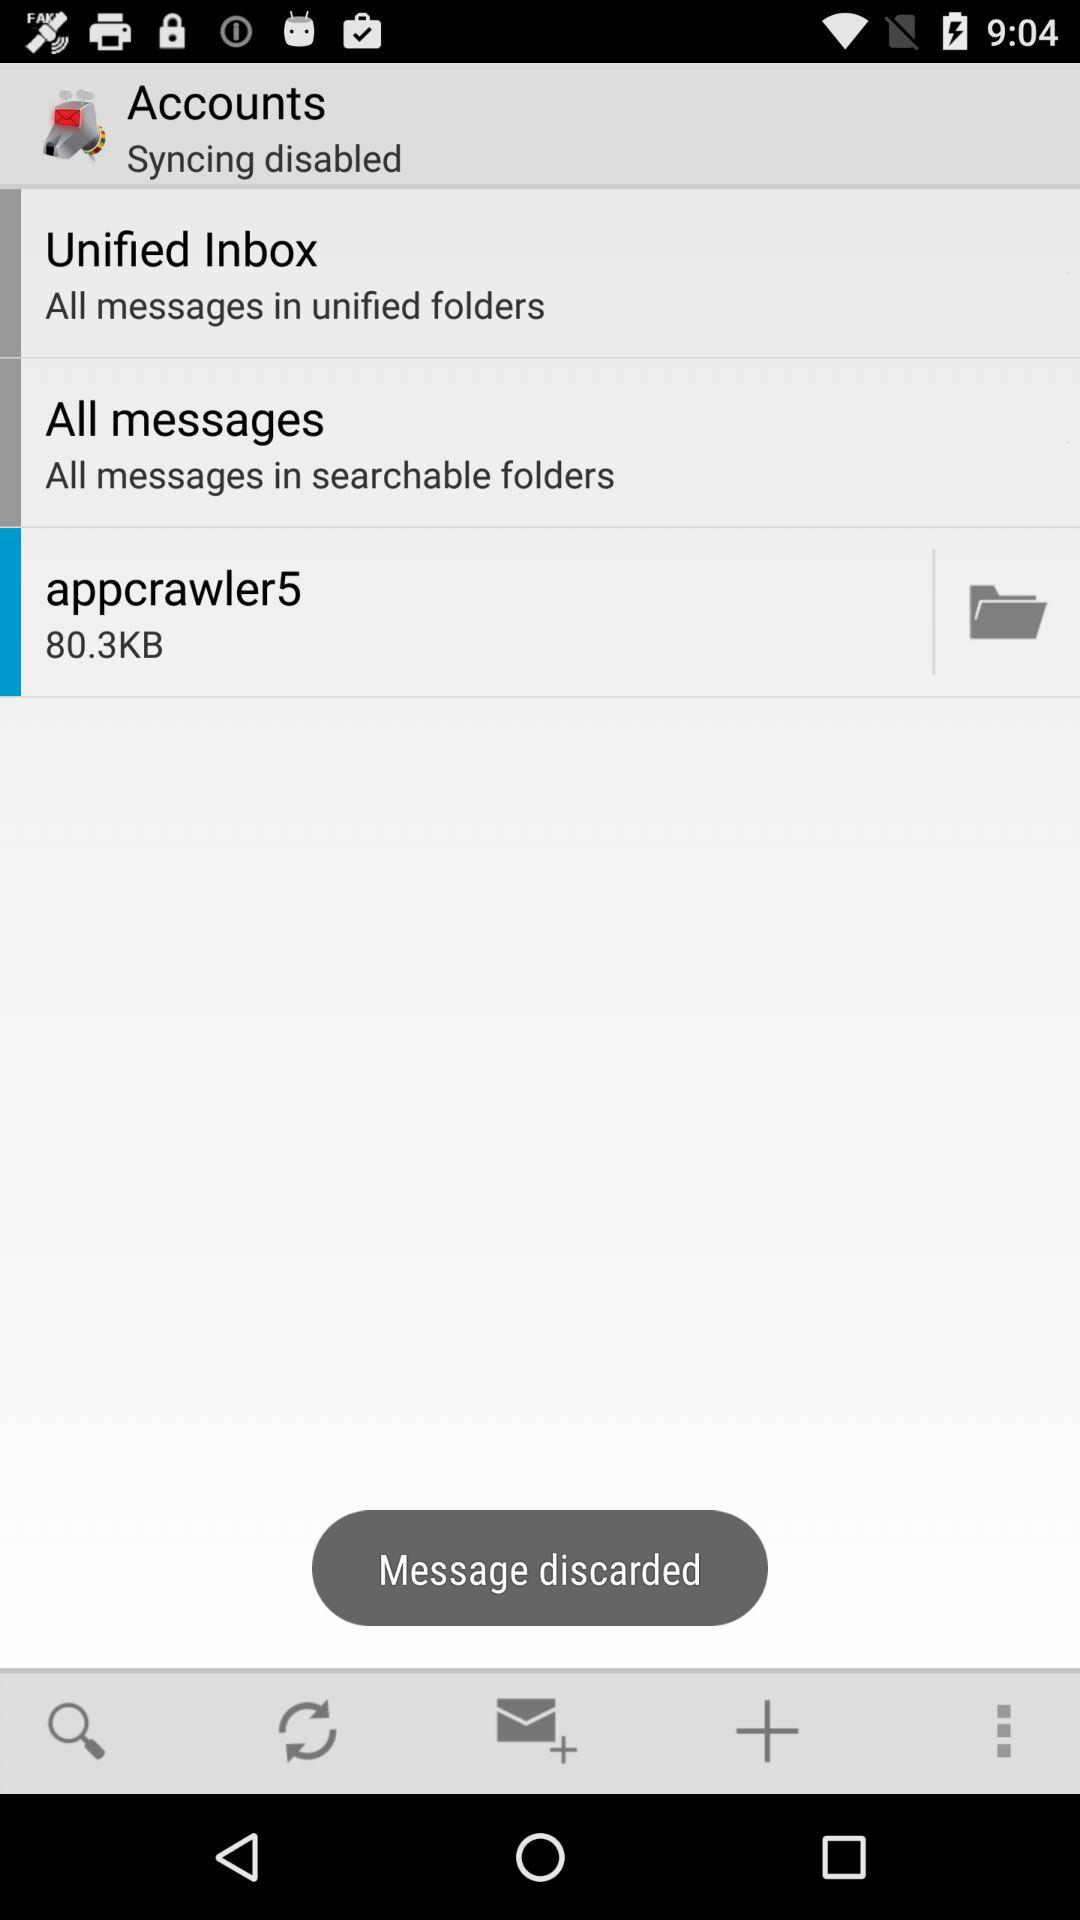How many KB is the "appcrawler5"? The size of "appcrawler5" is 80.3 KB. 